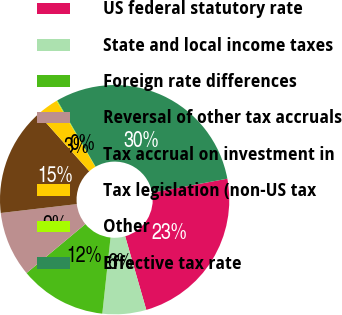Convert chart. <chart><loc_0><loc_0><loc_500><loc_500><pie_chart><fcel>US federal statutory rate<fcel>State and local income taxes<fcel>Foreign rate differences<fcel>Reversal of other tax accruals<fcel>Tax accrual on investment in<fcel>Tax legislation (non-US tax<fcel>Other<fcel>Effective tax rate<nl><fcel>23.48%<fcel>6.17%<fcel>12.23%<fcel>9.2%<fcel>15.26%<fcel>3.14%<fcel>0.11%<fcel>30.41%<nl></chart> 